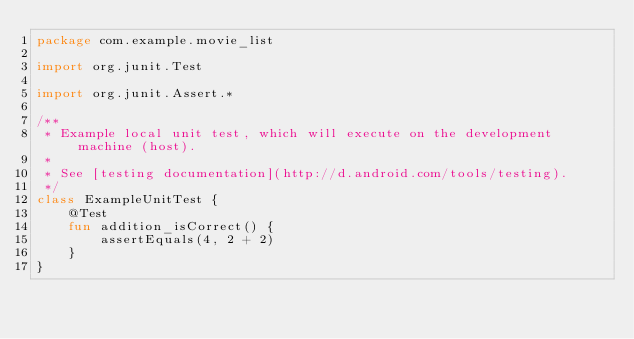Convert code to text. <code><loc_0><loc_0><loc_500><loc_500><_Kotlin_>package com.example.movie_list

import org.junit.Test

import org.junit.Assert.*

/**
 * Example local unit test, which will execute on the development machine (host).
 *
 * See [testing documentation](http://d.android.com/tools/testing).
 */
class ExampleUnitTest {
    @Test
    fun addition_isCorrect() {
        assertEquals(4, 2 + 2)
    }
}
</code> 